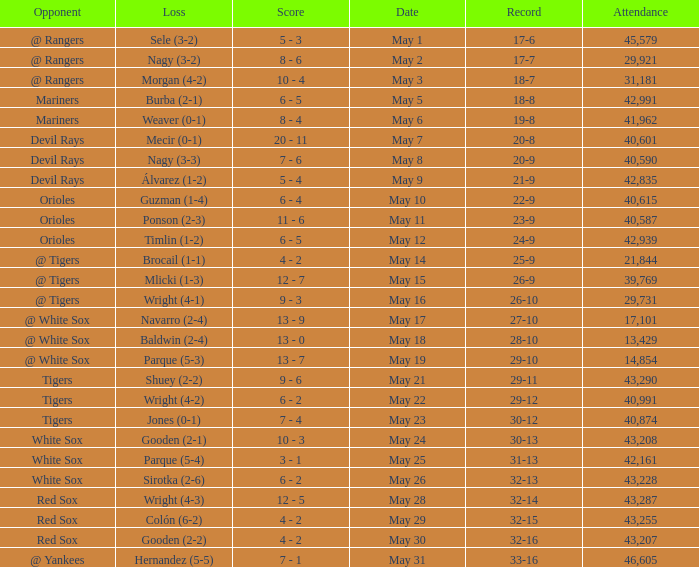What loss has 26-9 as a loss? Mlicki (1-3). 